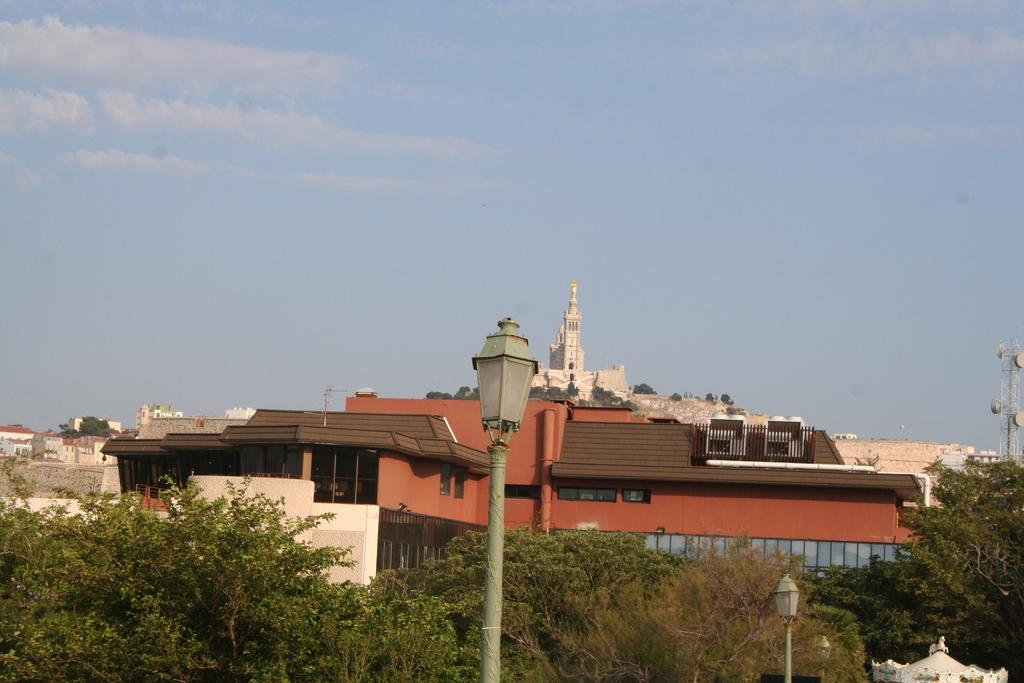What type of vegetation can be seen in the image? There are trees in the image. What color are the trees? The trees are green. What other structures are visible in the image? There are light poles in the image. What can be seen in the background of the image? There are buildings in the background of the image. What colors are the buildings? The buildings are brown and white. What is visible above the trees and buildings in the image? The sky is visible in the image. What colors can be seen in the sky? The sky is blue and white. Is there a veil covering the trees in the image? No, there is no veil present in the image. How does the love between the trees manifest in the image? There is no love between the trees depicted in the image, as trees do not have emotions or the ability to love. 